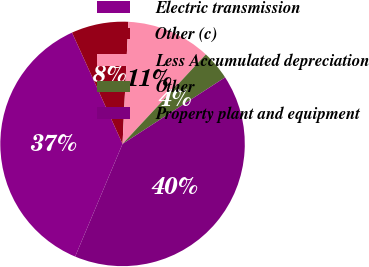<chart> <loc_0><loc_0><loc_500><loc_500><pie_chart><fcel>Electric transmission<fcel>Other (c)<fcel>Less Accumulated depreciation<fcel>Other<fcel>Property plant and equipment<nl><fcel>36.88%<fcel>7.54%<fcel>11.17%<fcel>3.91%<fcel>40.5%<nl></chart> 